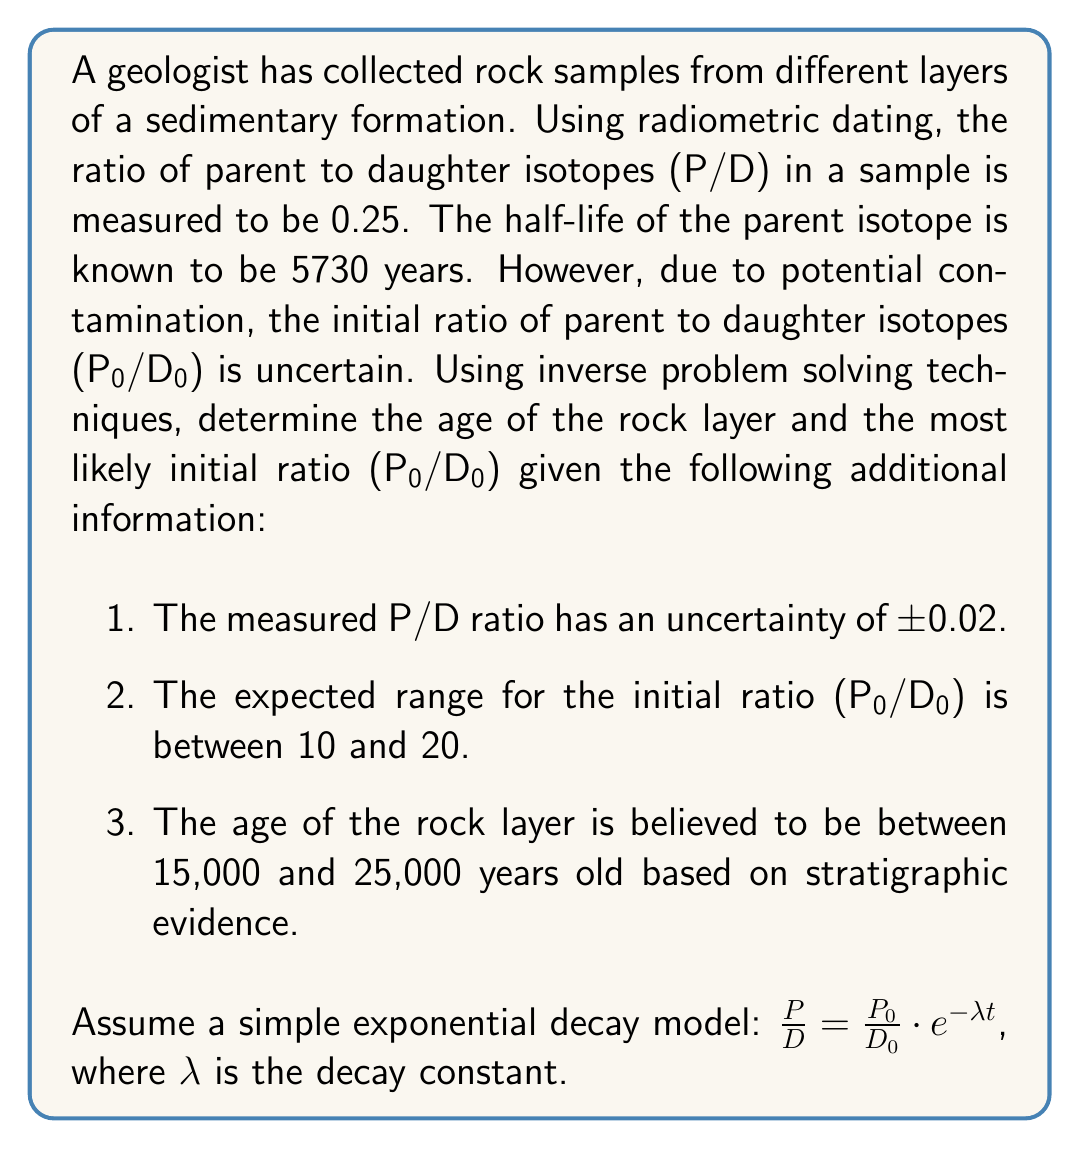Help me with this question. To solve this inverse problem, we'll use a combination of the given information and the radioactive decay equation. Let's approach this step-by-step:

1) First, calculate the decay constant λ:
   Half-life = 5730 years
   $\lambda = \frac{\ln(2)}{5730} \approx 1.209 \times 10^{-4}$ year⁻¹

2) The radioactive decay equation is:
   $\frac{P}{D} = \frac{P_0}{D_0} \cdot e^{-\lambda t}$

3) We can rearrange this to solve for t:
   $t = -\frac{1}{\lambda} \ln\left(\frac{P/D}{P_0/D_0}\right)$

4) Given the measured P/D ratio of 0.25 ± 0.02 and the possible range of P₀/D₀ from 10 to 20, we can calculate a range of possible ages:

   Minimum age: $t_{min} = -\frac{1}{1.209 \times 10^{-4}} \ln\left(\frac{0.27}{10}\right) \approx 15,300$ years
   Maximum age: $t_{max} = -\frac{1}{1.209 \times 10^{-4}} \ln\left(\frac{0.23}{20}\right) \approx 24,700$ years

5) This range aligns well with the stratigraphic evidence of 15,000 to 25,000 years.

6) To find the most likely age and initial ratio, we can use an optimization approach. The middle of our measured P/D range is 0.25, so let's use that.

7) We want to find P₀/D₀ that satisfies both our equation and falls within the expected range. We can do this by trying values and checking which one gives an age in the middle of our expected range (around 20,000 years):

   $20,000 = -\frac{1}{1.209 \times 10^{-4}} \ln\left(\frac{0.25}{P_0/D_0}\right)$

8) Solving this equation:
   $P_0/D_0 = 0.25 \cdot e^{20,000 \cdot 1.209 \times 10^{-4}} \approx 13.5$

9) This value falls within our expected range of 10 to 20 for P₀/D₀.

10) Using this P₀/D₀ value, we can calculate our best estimate for the age:
    $t = -\frac{1}{1.209 \times 10^{-4}} \ln\left(\frac{0.25}{13.5}\right) \approx 20,000$ years

Therefore, the most likely age of the rock layer is approximately 20,000 years, with an initial ratio (P₀/D₀) of about 13.5.
Answer: Age ≈ 20,000 years; Initial ratio (P₀/D₀) ≈ 13.5 